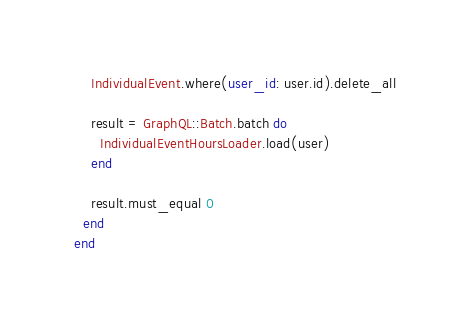Convert code to text. <code><loc_0><loc_0><loc_500><loc_500><_Ruby_>    IndividualEvent.where(user_id: user.id).delete_all

    result = GraphQL::Batch.batch do
      IndividualEventHoursLoader.load(user)
    end

    result.must_equal 0
  end
end
</code> 